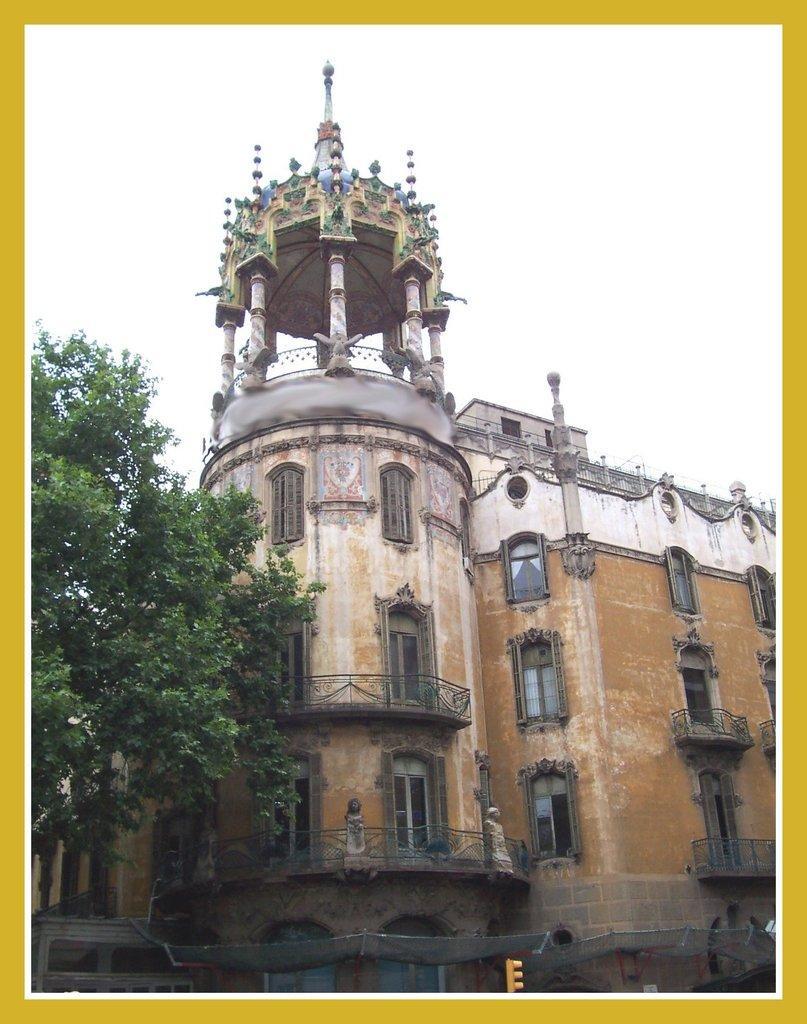Could you give a brief overview of what you see in this image? This is a poster card. In this image we can see a tree, building, windows, railing, traffic signal at the bottom and the sky. 